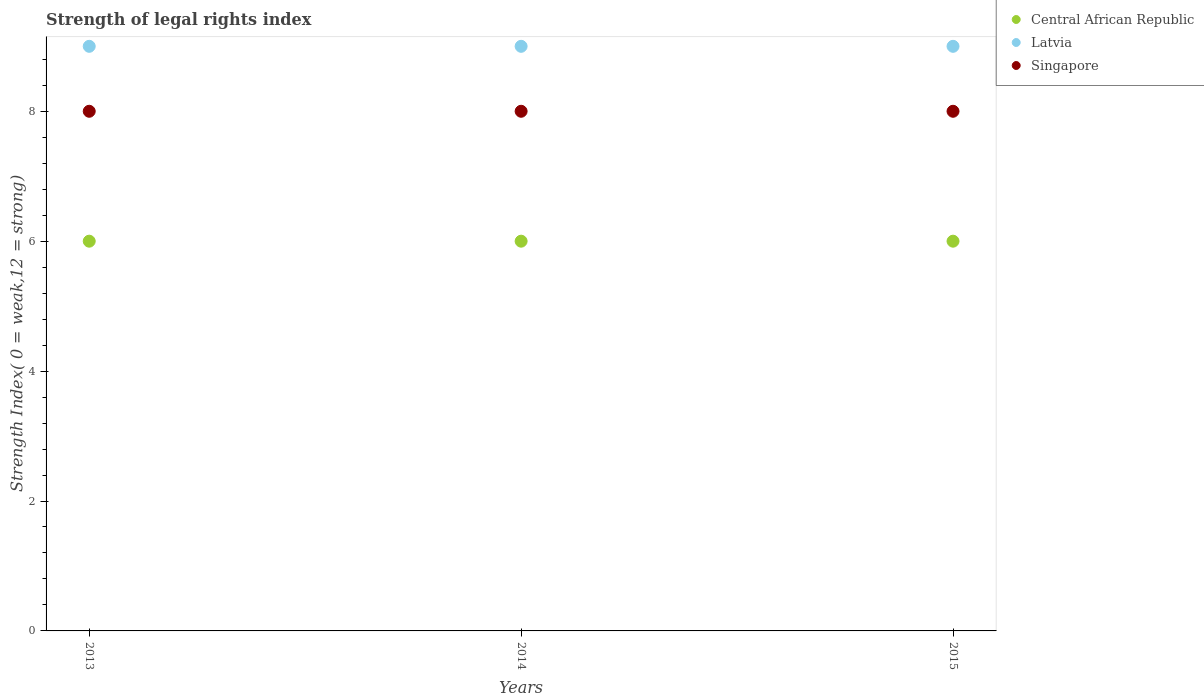How many different coloured dotlines are there?
Keep it short and to the point. 3. Is the number of dotlines equal to the number of legend labels?
Your answer should be compact. Yes. What is the strength index in Latvia in 2013?
Offer a terse response. 9. Across all years, what is the maximum strength index in Latvia?
Keep it short and to the point. 9. Across all years, what is the minimum strength index in Singapore?
Your answer should be very brief. 8. What is the total strength index in Singapore in the graph?
Your answer should be very brief. 24. What is the difference between the strength index in Latvia in 2015 and the strength index in Singapore in 2013?
Your answer should be very brief. 1. What is the average strength index in Latvia per year?
Your answer should be compact. 9. In the year 2013, what is the difference between the strength index in Singapore and strength index in Central African Republic?
Make the answer very short. 2. In how many years, is the strength index in Central African Republic greater than 8.4?
Your answer should be compact. 0. What is the ratio of the strength index in Central African Republic in 2013 to that in 2015?
Provide a succinct answer. 1. Is the difference between the strength index in Singapore in 2013 and 2014 greater than the difference between the strength index in Central African Republic in 2013 and 2014?
Your answer should be compact. No. What is the difference between the highest and the second highest strength index in Singapore?
Your answer should be compact. 0. What is the difference between the highest and the lowest strength index in Latvia?
Provide a succinct answer. 0. In how many years, is the strength index in Latvia greater than the average strength index in Latvia taken over all years?
Your response must be concise. 0. Is the sum of the strength index in Latvia in 2013 and 2014 greater than the maximum strength index in Central African Republic across all years?
Ensure brevity in your answer.  Yes. Does the strength index in Central African Republic monotonically increase over the years?
Your answer should be compact. No. Is the strength index in Latvia strictly less than the strength index in Singapore over the years?
Provide a succinct answer. No. How many dotlines are there?
Give a very brief answer. 3. What is the difference between two consecutive major ticks on the Y-axis?
Make the answer very short. 2. Does the graph contain any zero values?
Your answer should be compact. No. Does the graph contain grids?
Your answer should be very brief. No. Where does the legend appear in the graph?
Your answer should be compact. Top right. How many legend labels are there?
Offer a terse response. 3. How are the legend labels stacked?
Your response must be concise. Vertical. What is the title of the graph?
Your answer should be very brief. Strength of legal rights index. What is the label or title of the Y-axis?
Give a very brief answer. Strength Index( 0 = weak,12 = strong). What is the Strength Index( 0 = weak,12 = strong) in Latvia in 2013?
Keep it short and to the point. 9. What is the Strength Index( 0 = weak,12 = strong) of Singapore in 2014?
Ensure brevity in your answer.  8. What is the Strength Index( 0 = weak,12 = strong) in Latvia in 2015?
Offer a terse response. 9. Across all years, what is the maximum Strength Index( 0 = weak,12 = strong) in Latvia?
Make the answer very short. 9. What is the total Strength Index( 0 = weak,12 = strong) of Central African Republic in the graph?
Offer a terse response. 18. What is the difference between the Strength Index( 0 = weak,12 = strong) of Latvia in 2013 and that in 2014?
Your answer should be compact. 0. What is the difference between the Strength Index( 0 = weak,12 = strong) in Singapore in 2013 and that in 2014?
Give a very brief answer. 0. What is the difference between the Strength Index( 0 = weak,12 = strong) of Latvia in 2014 and that in 2015?
Keep it short and to the point. 0. What is the difference between the Strength Index( 0 = weak,12 = strong) of Singapore in 2014 and that in 2015?
Your response must be concise. 0. What is the difference between the Strength Index( 0 = weak,12 = strong) in Central African Republic in 2013 and the Strength Index( 0 = weak,12 = strong) in Latvia in 2014?
Offer a very short reply. -3. What is the difference between the Strength Index( 0 = weak,12 = strong) in Central African Republic in 2013 and the Strength Index( 0 = weak,12 = strong) in Singapore in 2014?
Give a very brief answer. -2. What is the difference between the Strength Index( 0 = weak,12 = strong) in Central African Republic in 2013 and the Strength Index( 0 = weak,12 = strong) in Singapore in 2015?
Give a very brief answer. -2. What is the difference between the Strength Index( 0 = weak,12 = strong) of Latvia in 2013 and the Strength Index( 0 = weak,12 = strong) of Singapore in 2015?
Your response must be concise. 1. What is the average Strength Index( 0 = weak,12 = strong) of Central African Republic per year?
Your answer should be very brief. 6. What is the average Strength Index( 0 = weak,12 = strong) of Singapore per year?
Your answer should be very brief. 8. In the year 2013, what is the difference between the Strength Index( 0 = weak,12 = strong) in Latvia and Strength Index( 0 = weak,12 = strong) in Singapore?
Give a very brief answer. 1. In the year 2014, what is the difference between the Strength Index( 0 = weak,12 = strong) of Central African Republic and Strength Index( 0 = weak,12 = strong) of Latvia?
Give a very brief answer. -3. In the year 2015, what is the difference between the Strength Index( 0 = weak,12 = strong) in Central African Republic and Strength Index( 0 = weak,12 = strong) in Latvia?
Your response must be concise. -3. In the year 2015, what is the difference between the Strength Index( 0 = weak,12 = strong) of Central African Republic and Strength Index( 0 = weak,12 = strong) of Singapore?
Make the answer very short. -2. What is the ratio of the Strength Index( 0 = weak,12 = strong) in Central African Republic in 2013 to that in 2014?
Your response must be concise. 1. What is the ratio of the Strength Index( 0 = weak,12 = strong) in Singapore in 2013 to that in 2014?
Give a very brief answer. 1. What is the ratio of the Strength Index( 0 = weak,12 = strong) in Latvia in 2013 to that in 2015?
Your response must be concise. 1. What is the ratio of the Strength Index( 0 = weak,12 = strong) of Latvia in 2014 to that in 2015?
Your response must be concise. 1. What is the difference between the highest and the second highest Strength Index( 0 = weak,12 = strong) of Central African Republic?
Offer a terse response. 0. What is the difference between the highest and the second highest Strength Index( 0 = weak,12 = strong) of Latvia?
Keep it short and to the point. 0. What is the difference between the highest and the lowest Strength Index( 0 = weak,12 = strong) in Central African Republic?
Provide a short and direct response. 0. What is the difference between the highest and the lowest Strength Index( 0 = weak,12 = strong) in Singapore?
Your answer should be compact. 0. 